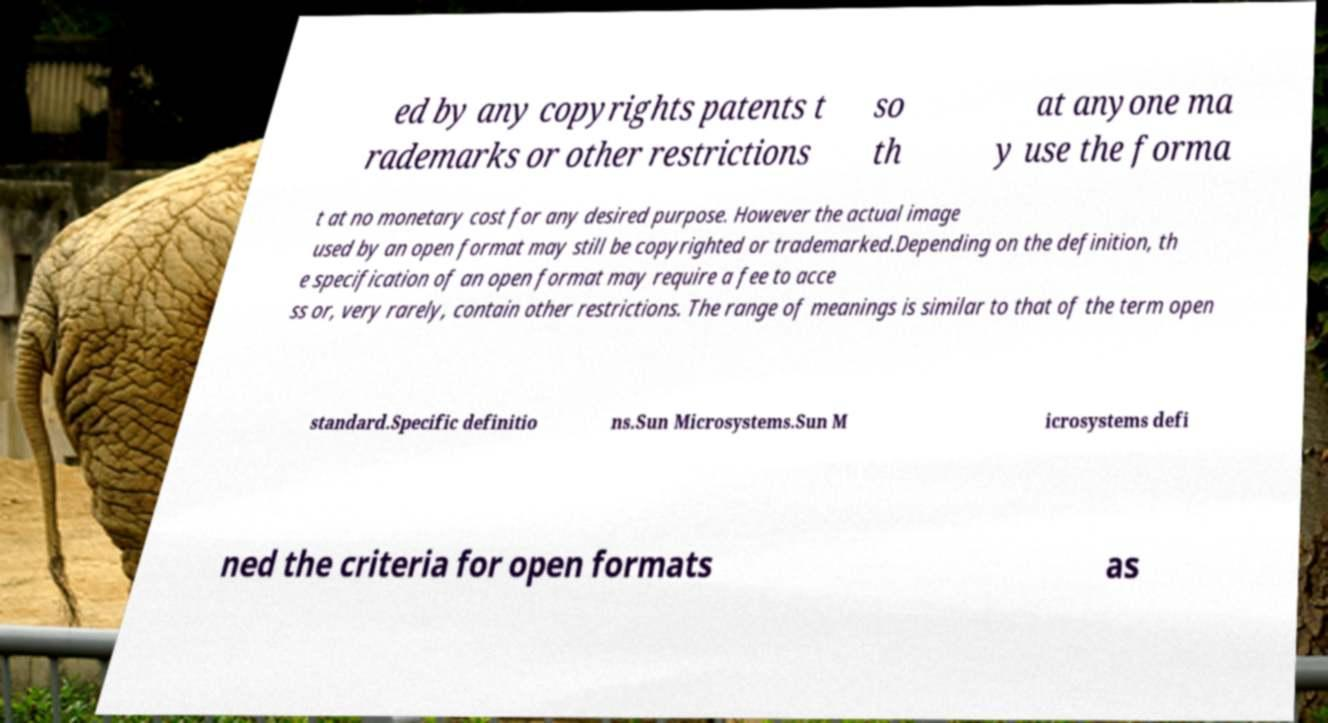For documentation purposes, I need the text within this image transcribed. Could you provide that? ed by any copyrights patents t rademarks or other restrictions so th at anyone ma y use the forma t at no monetary cost for any desired purpose. However the actual image used by an open format may still be copyrighted or trademarked.Depending on the definition, th e specification of an open format may require a fee to acce ss or, very rarely, contain other restrictions. The range of meanings is similar to that of the term open standard.Specific definitio ns.Sun Microsystems.Sun M icrosystems defi ned the criteria for open formats as 